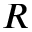Convert formula to latex. <formula><loc_0><loc_0><loc_500><loc_500>R</formula> 